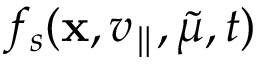Convert formula to latex. <formula><loc_0><loc_0><loc_500><loc_500>f _ { s } ( x , v _ { \| } , \tilde { \mu } , t )</formula> 